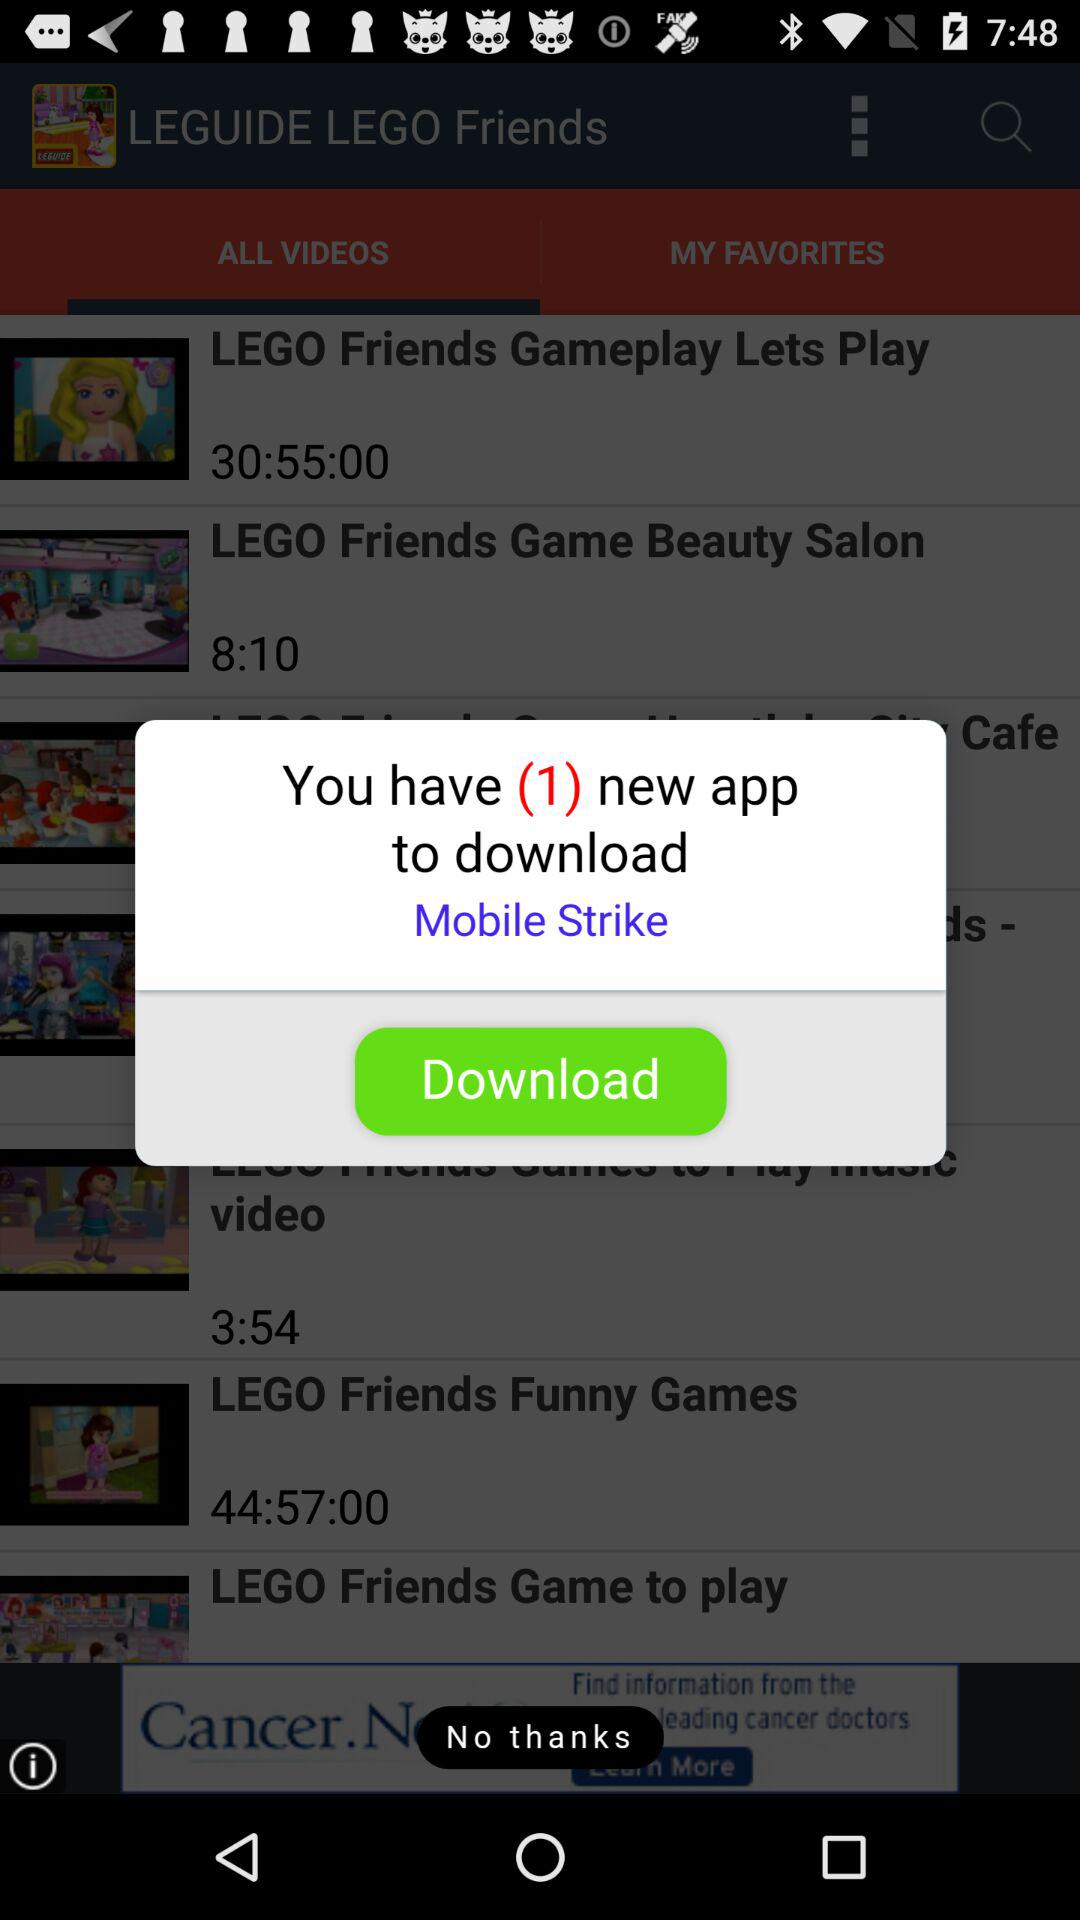How many new applications are there to download? There is 1 new application to download. 